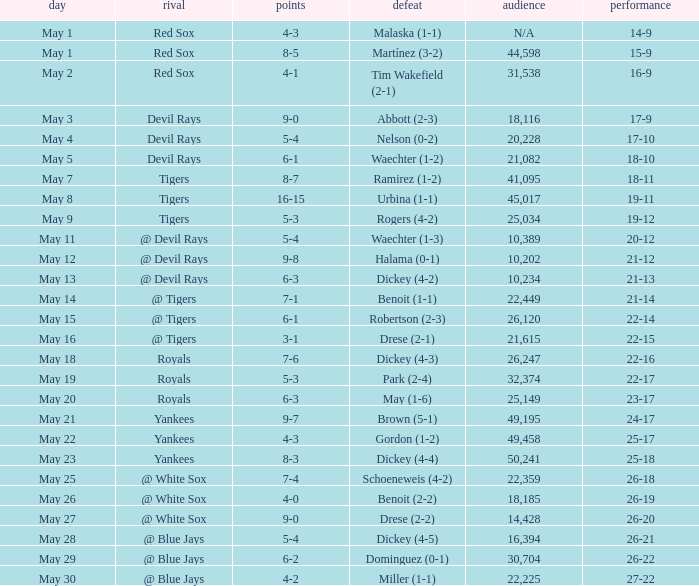Parse the table in full. {'header': ['day', 'rival', 'points', 'defeat', 'audience', 'performance'], 'rows': [['May 1', 'Red Sox', '4-3', 'Malaska (1-1)', 'N/A', '14-9'], ['May 1', 'Red Sox', '8-5', 'Martínez (3-2)', '44,598', '15-9'], ['May 2', 'Red Sox', '4-1', 'Tim Wakefield (2-1)', '31,538', '16-9'], ['May 3', 'Devil Rays', '9-0', 'Abbott (2-3)', '18,116', '17-9'], ['May 4', 'Devil Rays', '5-4', 'Nelson (0-2)', '20,228', '17-10'], ['May 5', 'Devil Rays', '6-1', 'Waechter (1-2)', '21,082', '18-10'], ['May 7', 'Tigers', '8-7', 'Ramirez (1-2)', '41,095', '18-11'], ['May 8', 'Tigers', '16-15', 'Urbina (1-1)', '45,017', '19-11'], ['May 9', 'Tigers', '5-3', 'Rogers (4-2)', '25,034', '19-12'], ['May 11', '@ Devil Rays', '5-4', 'Waechter (1-3)', '10,389', '20-12'], ['May 12', '@ Devil Rays', '9-8', 'Halama (0-1)', '10,202', '21-12'], ['May 13', '@ Devil Rays', '6-3', 'Dickey (4-2)', '10,234', '21-13'], ['May 14', '@ Tigers', '7-1', 'Benoit (1-1)', '22,449', '21-14'], ['May 15', '@ Tigers', '6-1', 'Robertson (2-3)', '26,120', '22-14'], ['May 16', '@ Tigers', '3-1', 'Drese (2-1)', '21,615', '22-15'], ['May 18', 'Royals', '7-6', 'Dickey (4-3)', '26,247', '22-16'], ['May 19', 'Royals', '5-3', 'Park (2-4)', '32,374', '22-17'], ['May 20', 'Royals', '6-3', 'May (1-6)', '25,149', '23-17'], ['May 21', 'Yankees', '9-7', 'Brown (5-1)', '49,195', '24-17'], ['May 22', 'Yankees', '4-3', 'Gordon (1-2)', '49,458', '25-17'], ['May 23', 'Yankees', '8-3', 'Dickey (4-4)', '50,241', '25-18'], ['May 25', '@ White Sox', '7-4', 'Schoeneweis (4-2)', '22,359', '26-18'], ['May 26', '@ White Sox', '4-0', 'Benoit (2-2)', '18,185', '26-19'], ['May 27', '@ White Sox', '9-0', 'Drese (2-2)', '14,428', '26-20'], ['May 28', '@ Blue Jays', '5-4', 'Dickey (4-5)', '16,394', '26-21'], ['May 29', '@ Blue Jays', '6-2', 'Dominguez (0-1)', '30,704', '26-22'], ['May 30', '@ Blue Jays', '4-2', 'Miller (1-1)', '22,225', '27-22']]} What was the score of the game that had a loss of Drese (2-2)? 9-0. 